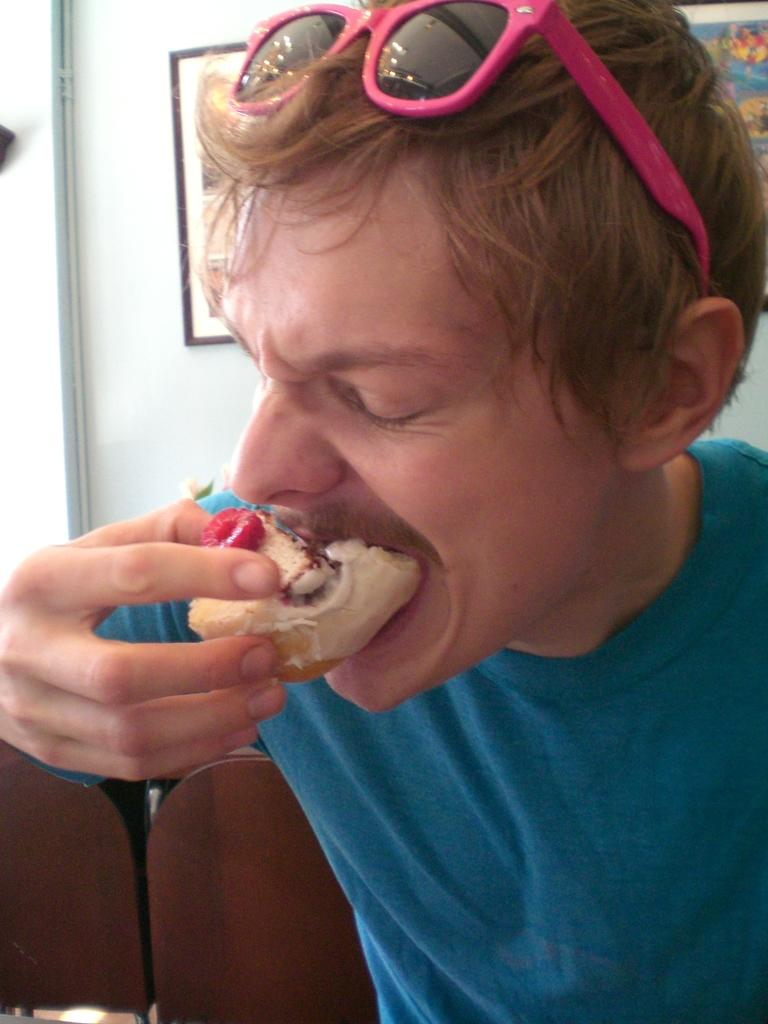What is happening in the image? There is a person in the image who is eating food. What else can be seen in the image? There are pictures on the wall. What type of celery is the person eating in the image? There is no celery present in the image; the person is eating food, but the specific type of food is not mentioned. 